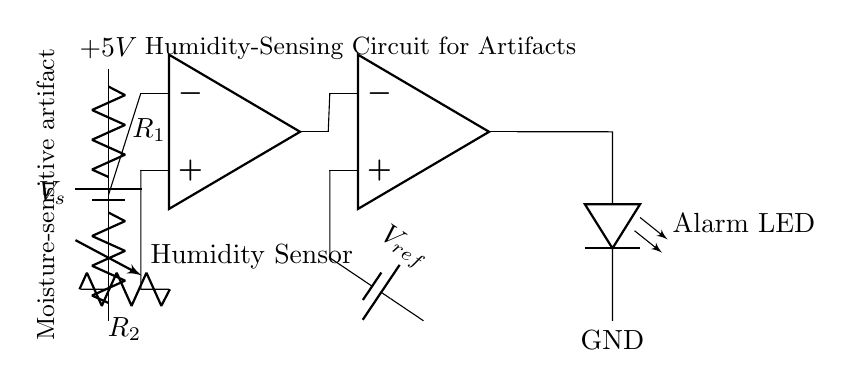What type of sensor is used in this circuit? The circuit diagram indicates the presence of a "Humidity Sensor," which is shown as a variable resistor connected to the voltage divider. This resistor changes its resistance based on the humidity level, thereby sensing moisture levels.
Answer: Humidity Sensor What is the purpose of the operational amplifier in this circuit? The operational amplifier serves as a signal conditioner, amplifying the output from the voltage divider to a level suitable for comparison against a reference voltage. This allows it to detect when humidity exceeds a certain threshold, triggering an output event.
Answer: Signal conditioning What is the reference voltage used in this circuit? The diagram indicates a battery labeled "V_ref" as the reference voltage input for the comparator section of the op-amp, which essentially provides a threshold for humidity detection.
Answer: V_ref How many resistors are present in this circuit? Observing the circuit, there are two resistors labeled as R1 and R2, both used in the voltage division and conditioning process of the humidity sensing mechanism.
Answer: Two What condition will activate the Alarm LED? The Alarm LED will activate when the output of the comparator becomes high, which occurs when the humidity level exceeds the set reference voltage. This action indicates a need for attention to prevent damage to moisture-sensitive artifacts.
Answer: High humidity What is the voltage supply for the circuit? The voltage supply is explicitly marked as "V_s," and in the context of typical circuits, it often assumes a supply of 5 volts. This voltage powers the entire circuit, including the sensors and operational amplifiers.
Answer: 5V What does the vertical label indicate about the location of the moisture-sensitive artifact? The label indicates that the moisture-sensitive artifact is located at that position in the circuit diagram, specifically connected to the variable resistor representing the humidity sensor. This specifies the component's direct relationship to the artifacts being protected.
Answer: Moisture-sensitive artifact 